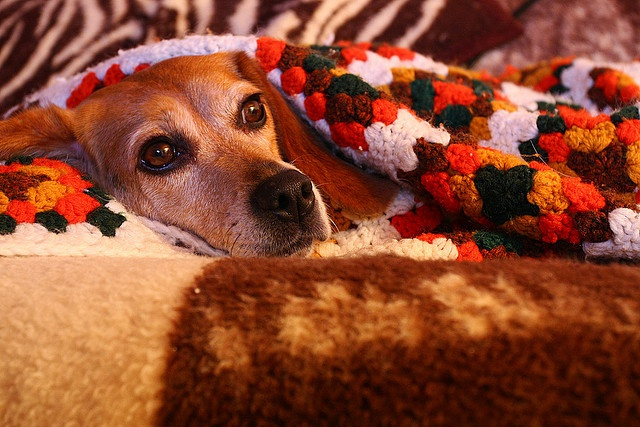Describe the objects in this image and their specific colors. I can see bed in maroon, black, and tan tones and dog in maroon, black, and brown tones in this image. 